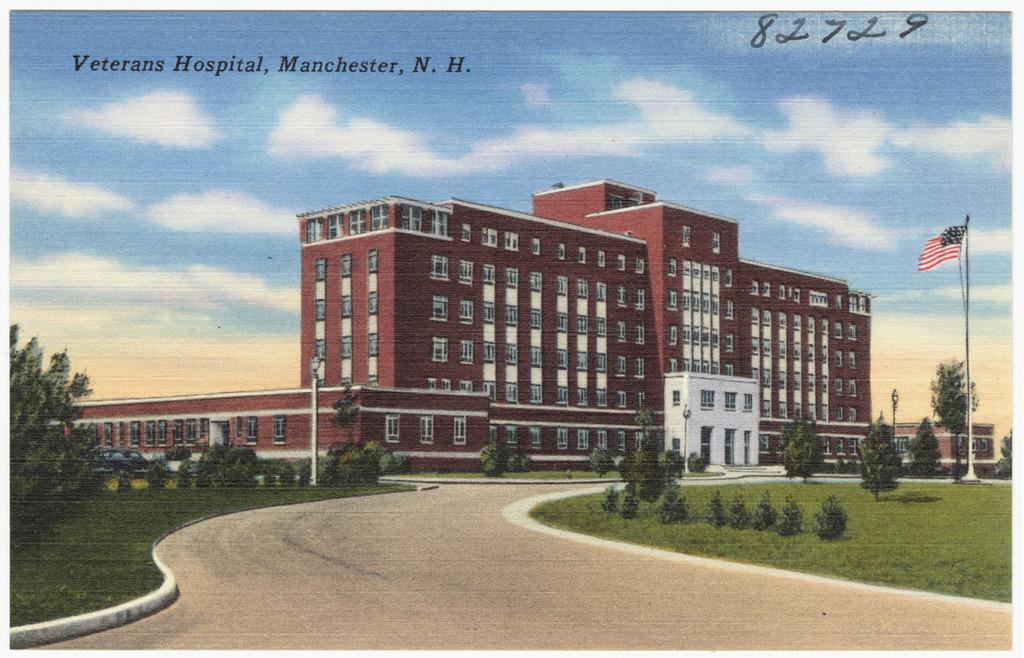Please provide a concise description of this image. In this image I can see few trees in green color, the flag is in blue, white and red color and I can also see few light poles. Background the building is in brown and white color and the sky is in blue and white color. 